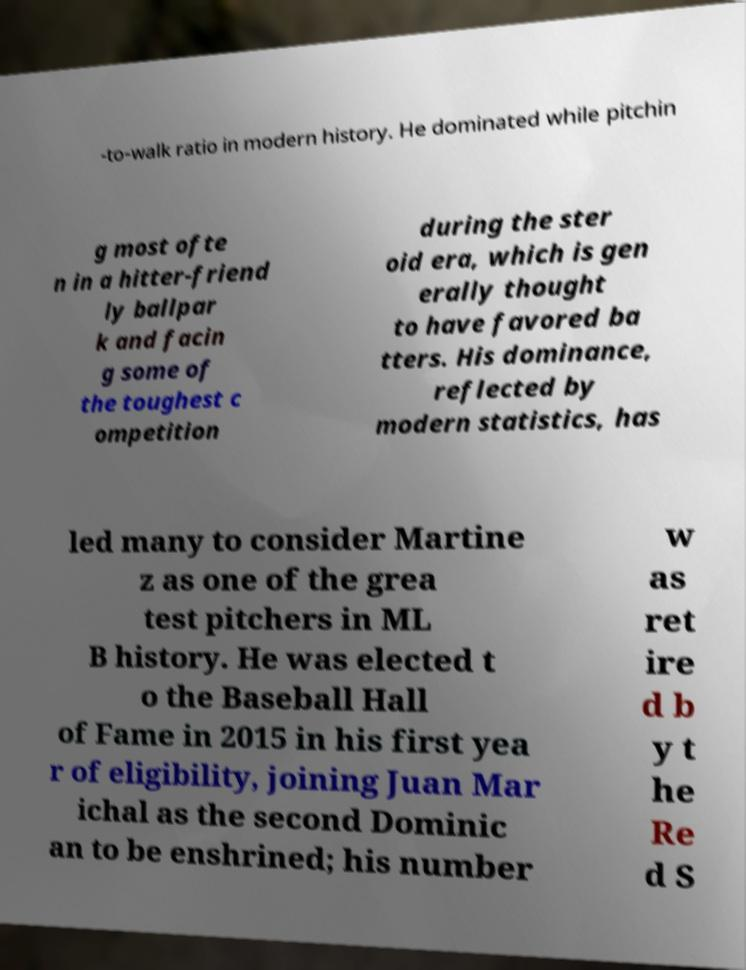Can you read and provide the text displayed in the image?This photo seems to have some interesting text. Can you extract and type it out for me? -to-walk ratio in modern history. He dominated while pitchin g most ofte n in a hitter-friend ly ballpar k and facin g some of the toughest c ompetition during the ster oid era, which is gen erally thought to have favored ba tters. His dominance, reflected by modern statistics, has led many to consider Martine z as one of the grea test pitchers in ML B history. He was elected t o the Baseball Hall of Fame in 2015 in his first yea r of eligibility, joining Juan Mar ichal as the second Dominic an to be enshrined; his number w as ret ire d b y t he Re d S 